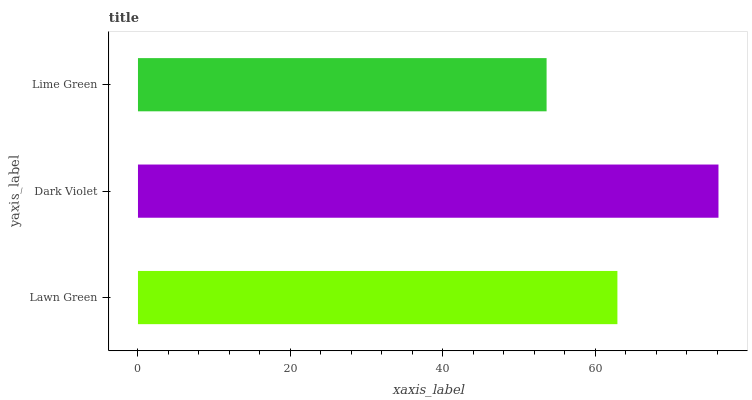Is Lime Green the minimum?
Answer yes or no. Yes. Is Dark Violet the maximum?
Answer yes or no. Yes. Is Dark Violet the minimum?
Answer yes or no. No. Is Lime Green the maximum?
Answer yes or no. No. Is Dark Violet greater than Lime Green?
Answer yes or no. Yes. Is Lime Green less than Dark Violet?
Answer yes or no. Yes. Is Lime Green greater than Dark Violet?
Answer yes or no. No. Is Dark Violet less than Lime Green?
Answer yes or no. No. Is Lawn Green the high median?
Answer yes or no. Yes. Is Lawn Green the low median?
Answer yes or no. Yes. Is Dark Violet the high median?
Answer yes or no. No. Is Dark Violet the low median?
Answer yes or no. No. 